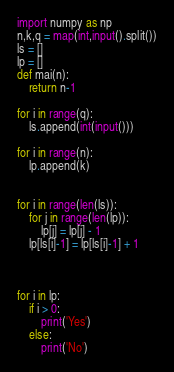<code> <loc_0><loc_0><loc_500><loc_500><_Python_>import numpy as np
n,k,q = map(int,input().split())
ls = []
lp = []
def mai(n):
    return n-1

for i in range(q):
    ls.append(int(input()))

for i in range(n):
    lp.append(k)


for i in range(len(ls)):
    for j in range(len(lp)):
        lp[j] = lp[j] - 1
    lp[ls[i]-1] = lp[ls[i]-1] + 1



for i in lp:
    if i > 0:
        print('Yes')
    else:
        print('No')


</code> 